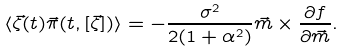<formula> <loc_0><loc_0><loc_500><loc_500>\langle \vec { \zeta } ( t ) \vec { \pi } ( t , [ \vec { \zeta } ] ) \rangle = - \frac { \sigma ^ { 2 } } { 2 ( 1 + \alpha ^ { 2 } ) } \vec { m } \times \frac { \partial f } { \partial \vec { m } } .</formula> 